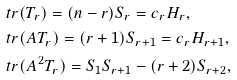Convert formula to latex. <formula><loc_0><loc_0><loc_500><loc_500>& \ t r ( T _ { r } ) = ( n - r ) S _ { r } = c _ { r } H _ { r } , \\ & \ t r ( A T _ { r } ) = ( r + 1 ) S _ { r + 1 } = c _ { r } H _ { r + 1 } , \\ & \ t r ( A ^ { 2 } T _ { r } ) = S _ { 1 } S _ { r + 1 } - ( r + 2 ) S _ { r + 2 } ,</formula> 